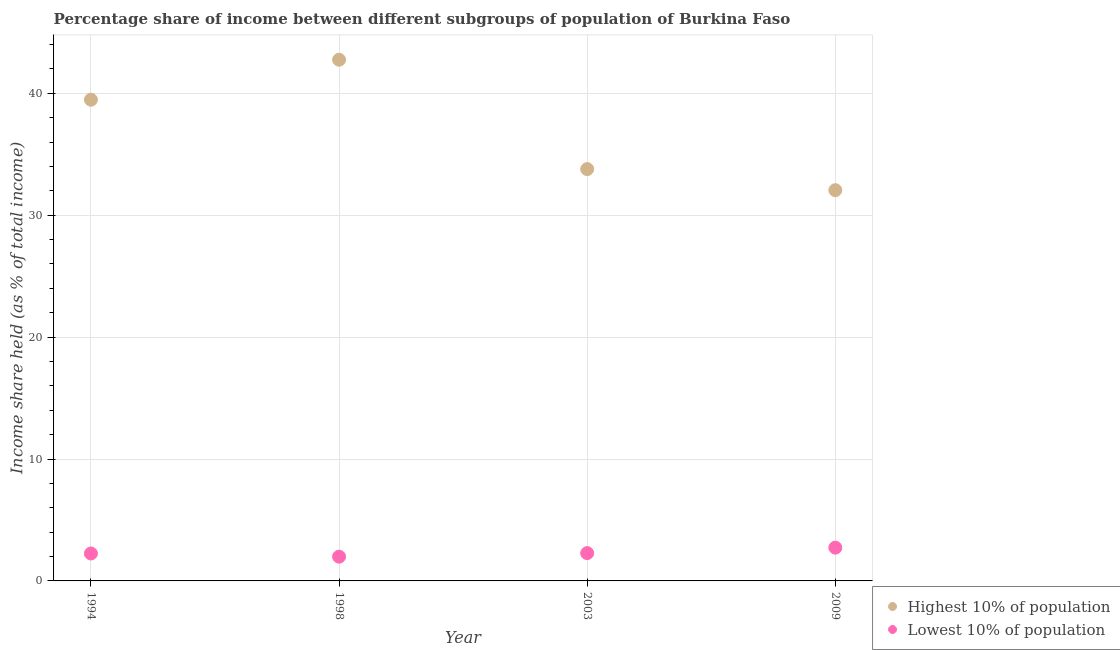How many different coloured dotlines are there?
Ensure brevity in your answer.  2. Is the number of dotlines equal to the number of legend labels?
Your answer should be very brief. Yes. What is the income share held by lowest 10% of the population in 1998?
Your answer should be very brief. 1.99. Across all years, what is the maximum income share held by lowest 10% of the population?
Offer a terse response. 2.73. Across all years, what is the minimum income share held by highest 10% of the population?
Provide a succinct answer. 32.05. What is the total income share held by lowest 10% of the population in the graph?
Give a very brief answer. 9.25. What is the difference between the income share held by highest 10% of the population in 1994 and that in 2009?
Keep it short and to the point. 7.42. What is the difference between the income share held by lowest 10% of the population in 2003 and the income share held by highest 10% of the population in 2009?
Provide a short and direct response. -29.77. What is the average income share held by lowest 10% of the population per year?
Your response must be concise. 2.31. In the year 1994, what is the difference between the income share held by lowest 10% of the population and income share held by highest 10% of the population?
Give a very brief answer. -37.22. What is the ratio of the income share held by lowest 10% of the population in 1998 to that in 2003?
Your answer should be very brief. 0.87. Is the difference between the income share held by lowest 10% of the population in 1994 and 1998 greater than the difference between the income share held by highest 10% of the population in 1994 and 1998?
Offer a terse response. Yes. What is the difference between the highest and the second highest income share held by highest 10% of the population?
Ensure brevity in your answer.  3.28. What is the difference between the highest and the lowest income share held by highest 10% of the population?
Keep it short and to the point. 10.7. In how many years, is the income share held by highest 10% of the population greater than the average income share held by highest 10% of the population taken over all years?
Keep it short and to the point. 2. Is the income share held by lowest 10% of the population strictly less than the income share held by highest 10% of the population over the years?
Keep it short and to the point. Yes. What is the difference between two consecutive major ticks on the Y-axis?
Make the answer very short. 10. Does the graph contain any zero values?
Your answer should be very brief. No. Does the graph contain grids?
Offer a very short reply. Yes. How many legend labels are there?
Make the answer very short. 2. How are the legend labels stacked?
Provide a short and direct response. Vertical. What is the title of the graph?
Provide a short and direct response. Percentage share of income between different subgroups of population of Burkina Faso. Does "Enforce a contract" appear as one of the legend labels in the graph?
Provide a short and direct response. No. What is the label or title of the X-axis?
Your answer should be very brief. Year. What is the label or title of the Y-axis?
Provide a short and direct response. Income share held (as % of total income). What is the Income share held (as % of total income) in Highest 10% of population in 1994?
Give a very brief answer. 39.47. What is the Income share held (as % of total income) of Lowest 10% of population in 1994?
Ensure brevity in your answer.  2.25. What is the Income share held (as % of total income) in Highest 10% of population in 1998?
Provide a short and direct response. 42.75. What is the Income share held (as % of total income) in Lowest 10% of population in 1998?
Provide a short and direct response. 1.99. What is the Income share held (as % of total income) in Highest 10% of population in 2003?
Offer a terse response. 33.78. What is the Income share held (as % of total income) of Lowest 10% of population in 2003?
Provide a short and direct response. 2.28. What is the Income share held (as % of total income) in Highest 10% of population in 2009?
Your answer should be compact. 32.05. What is the Income share held (as % of total income) in Lowest 10% of population in 2009?
Keep it short and to the point. 2.73. Across all years, what is the maximum Income share held (as % of total income) in Highest 10% of population?
Your response must be concise. 42.75. Across all years, what is the maximum Income share held (as % of total income) of Lowest 10% of population?
Your response must be concise. 2.73. Across all years, what is the minimum Income share held (as % of total income) in Highest 10% of population?
Keep it short and to the point. 32.05. Across all years, what is the minimum Income share held (as % of total income) of Lowest 10% of population?
Your answer should be very brief. 1.99. What is the total Income share held (as % of total income) of Highest 10% of population in the graph?
Offer a very short reply. 148.05. What is the total Income share held (as % of total income) of Lowest 10% of population in the graph?
Make the answer very short. 9.25. What is the difference between the Income share held (as % of total income) of Highest 10% of population in 1994 and that in 1998?
Offer a very short reply. -3.28. What is the difference between the Income share held (as % of total income) of Lowest 10% of population in 1994 and that in 1998?
Offer a terse response. 0.26. What is the difference between the Income share held (as % of total income) in Highest 10% of population in 1994 and that in 2003?
Ensure brevity in your answer.  5.69. What is the difference between the Income share held (as % of total income) of Lowest 10% of population in 1994 and that in 2003?
Offer a very short reply. -0.03. What is the difference between the Income share held (as % of total income) in Highest 10% of population in 1994 and that in 2009?
Make the answer very short. 7.42. What is the difference between the Income share held (as % of total income) in Lowest 10% of population in 1994 and that in 2009?
Your answer should be compact. -0.48. What is the difference between the Income share held (as % of total income) in Highest 10% of population in 1998 and that in 2003?
Provide a short and direct response. 8.97. What is the difference between the Income share held (as % of total income) in Lowest 10% of population in 1998 and that in 2003?
Offer a terse response. -0.29. What is the difference between the Income share held (as % of total income) in Lowest 10% of population in 1998 and that in 2009?
Provide a short and direct response. -0.74. What is the difference between the Income share held (as % of total income) of Highest 10% of population in 2003 and that in 2009?
Offer a very short reply. 1.73. What is the difference between the Income share held (as % of total income) in Lowest 10% of population in 2003 and that in 2009?
Make the answer very short. -0.45. What is the difference between the Income share held (as % of total income) in Highest 10% of population in 1994 and the Income share held (as % of total income) in Lowest 10% of population in 1998?
Keep it short and to the point. 37.48. What is the difference between the Income share held (as % of total income) in Highest 10% of population in 1994 and the Income share held (as % of total income) in Lowest 10% of population in 2003?
Your answer should be compact. 37.19. What is the difference between the Income share held (as % of total income) of Highest 10% of population in 1994 and the Income share held (as % of total income) of Lowest 10% of population in 2009?
Give a very brief answer. 36.74. What is the difference between the Income share held (as % of total income) in Highest 10% of population in 1998 and the Income share held (as % of total income) in Lowest 10% of population in 2003?
Keep it short and to the point. 40.47. What is the difference between the Income share held (as % of total income) of Highest 10% of population in 1998 and the Income share held (as % of total income) of Lowest 10% of population in 2009?
Ensure brevity in your answer.  40.02. What is the difference between the Income share held (as % of total income) of Highest 10% of population in 2003 and the Income share held (as % of total income) of Lowest 10% of population in 2009?
Make the answer very short. 31.05. What is the average Income share held (as % of total income) in Highest 10% of population per year?
Your response must be concise. 37.01. What is the average Income share held (as % of total income) in Lowest 10% of population per year?
Your answer should be very brief. 2.31. In the year 1994, what is the difference between the Income share held (as % of total income) of Highest 10% of population and Income share held (as % of total income) of Lowest 10% of population?
Give a very brief answer. 37.22. In the year 1998, what is the difference between the Income share held (as % of total income) of Highest 10% of population and Income share held (as % of total income) of Lowest 10% of population?
Provide a short and direct response. 40.76. In the year 2003, what is the difference between the Income share held (as % of total income) of Highest 10% of population and Income share held (as % of total income) of Lowest 10% of population?
Provide a short and direct response. 31.5. In the year 2009, what is the difference between the Income share held (as % of total income) in Highest 10% of population and Income share held (as % of total income) in Lowest 10% of population?
Your answer should be compact. 29.32. What is the ratio of the Income share held (as % of total income) of Highest 10% of population in 1994 to that in 1998?
Make the answer very short. 0.92. What is the ratio of the Income share held (as % of total income) in Lowest 10% of population in 1994 to that in 1998?
Keep it short and to the point. 1.13. What is the ratio of the Income share held (as % of total income) of Highest 10% of population in 1994 to that in 2003?
Make the answer very short. 1.17. What is the ratio of the Income share held (as % of total income) of Highest 10% of population in 1994 to that in 2009?
Offer a terse response. 1.23. What is the ratio of the Income share held (as % of total income) of Lowest 10% of population in 1994 to that in 2009?
Ensure brevity in your answer.  0.82. What is the ratio of the Income share held (as % of total income) in Highest 10% of population in 1998 to that in 2003?
Your answer should be compact. 1.27. What is the ratio of the Income share held (as % of total income) in Lowest 10% of population in 1998 to that in 2003?
Your answer should be compact. 0.87. What is the ratio of the Income share held (as % of total income) of Highest 10% of population in 1998 to that in 2009?
Your answer should be compact. 1.33. What is the ratio of the Income share held (as % of total income) in Lowest 10% of population in 1998 to that in 2009?
Keep it short and to the point. 0.73. What is the ratio of the Income share held (as % of total income) in Highest 10% of population in 2003 to that in 2009?
Give a very brief answer. 1.05. What is the ratio of the Income share held (as % of total income) of Lowest 10% of population in 2003 to that in 2009?
Ensure brevity in your answer.  0.84. What is the difference between the highest and the second highest Income share held (as % of total income) of Highest 10% of population?
Keep it short and to the point. 3.28. What is the difference between the highest and the second highest Income share held (as % of total income) of Lowest 10% of population?
Your answer should be very brief. 0.45. What is the difference between the highest and the lowest Income share held (as % of total income) in Lowest 10% of population?
Offer a very short reply. 0.74. 